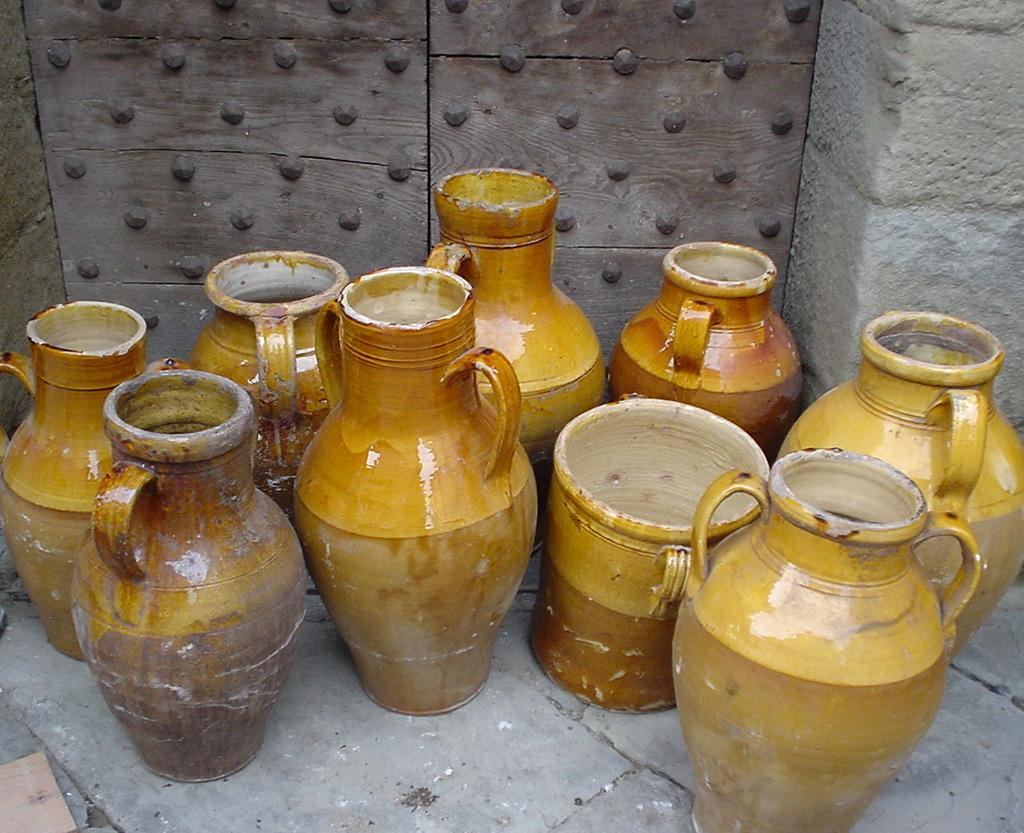What objects are present in the image? There are cases in the image. What is the color of the cases? The cases are brown in color. What can be seen in the background of the image? There is a wooden door and a wall in the background of the image. What is attached to the wooden door? There are nails on the wooden door. What type of train can be seen passing by in the image? There is no train present in the image. How does the acoustics of the room affect the sound of the cases in the image? The provided facts do not mention anything about the acoustics of the room, so we cannot determine how it affects the sound of the cases. 